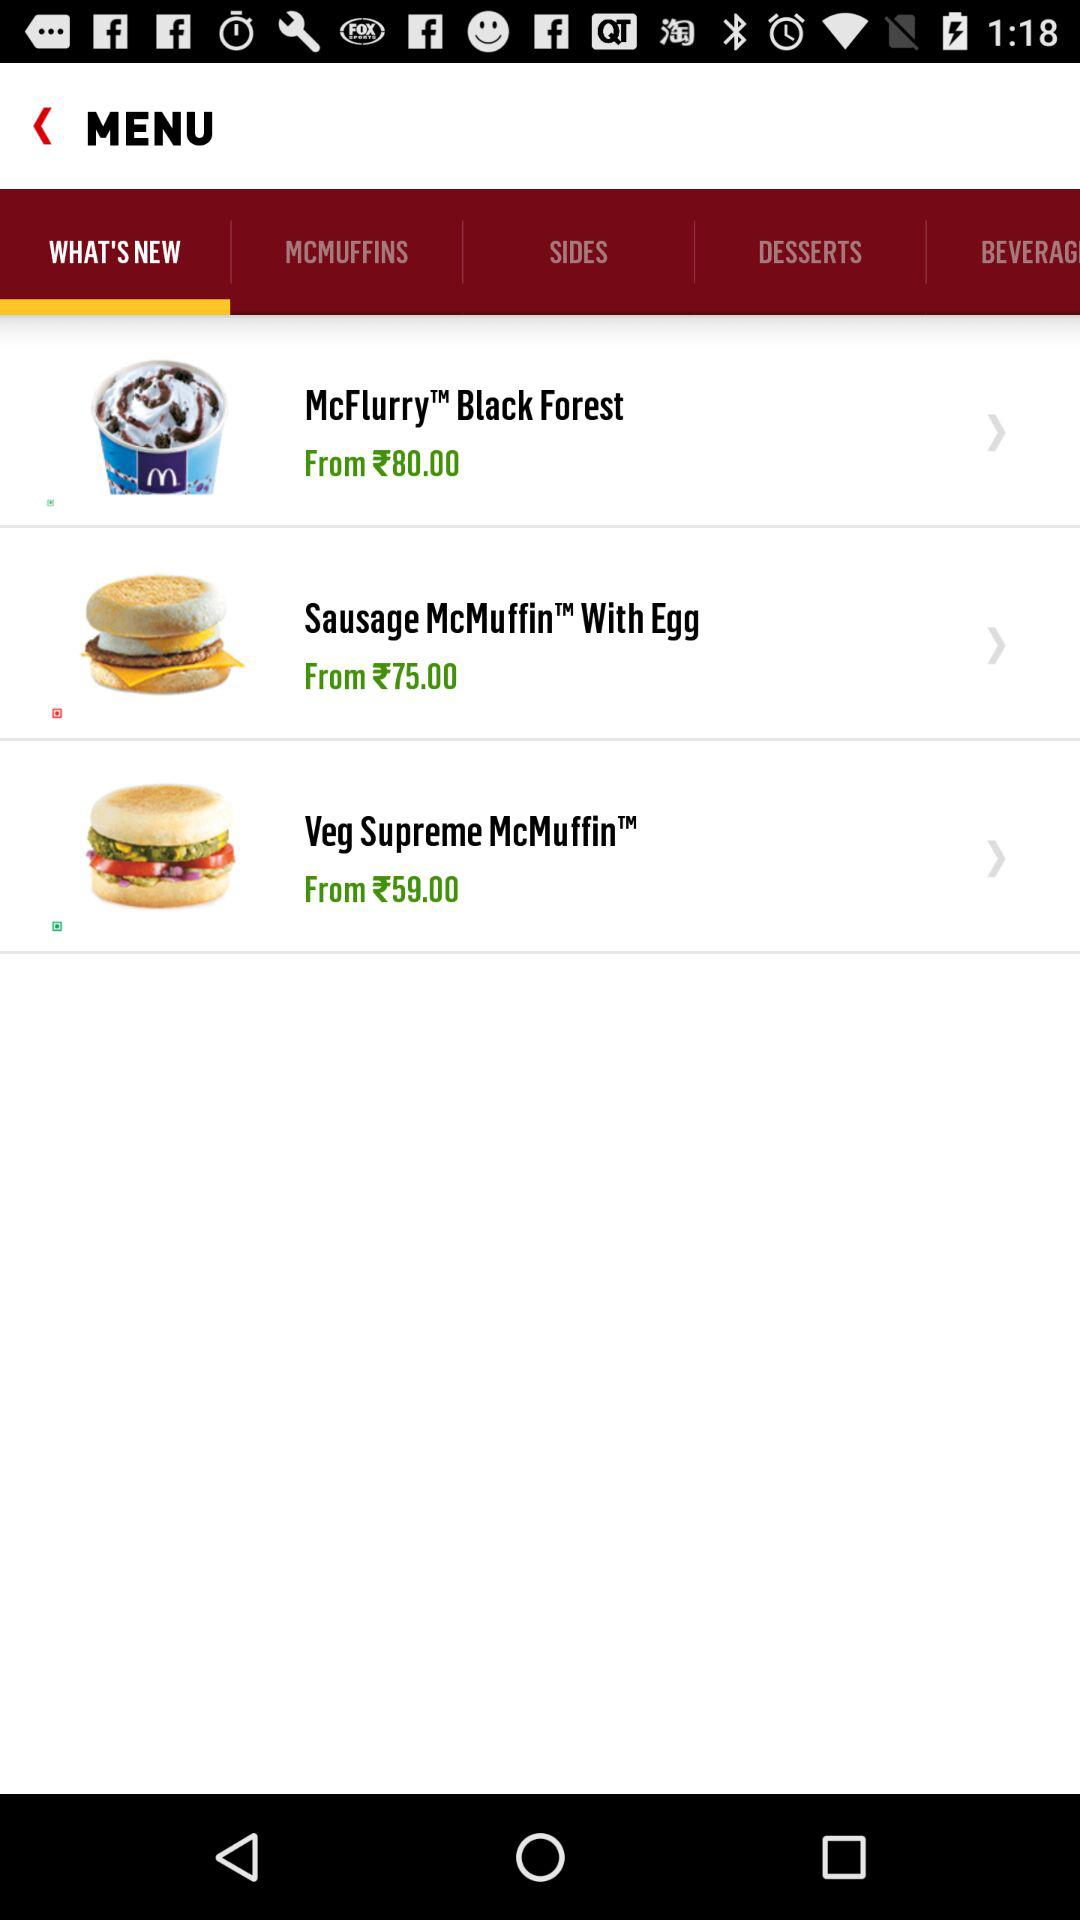What is the price of "Sausage McMuffin™ With Egg"? The price of "Sausage McMuffin™ With Egg" starts from 75 rupees. 